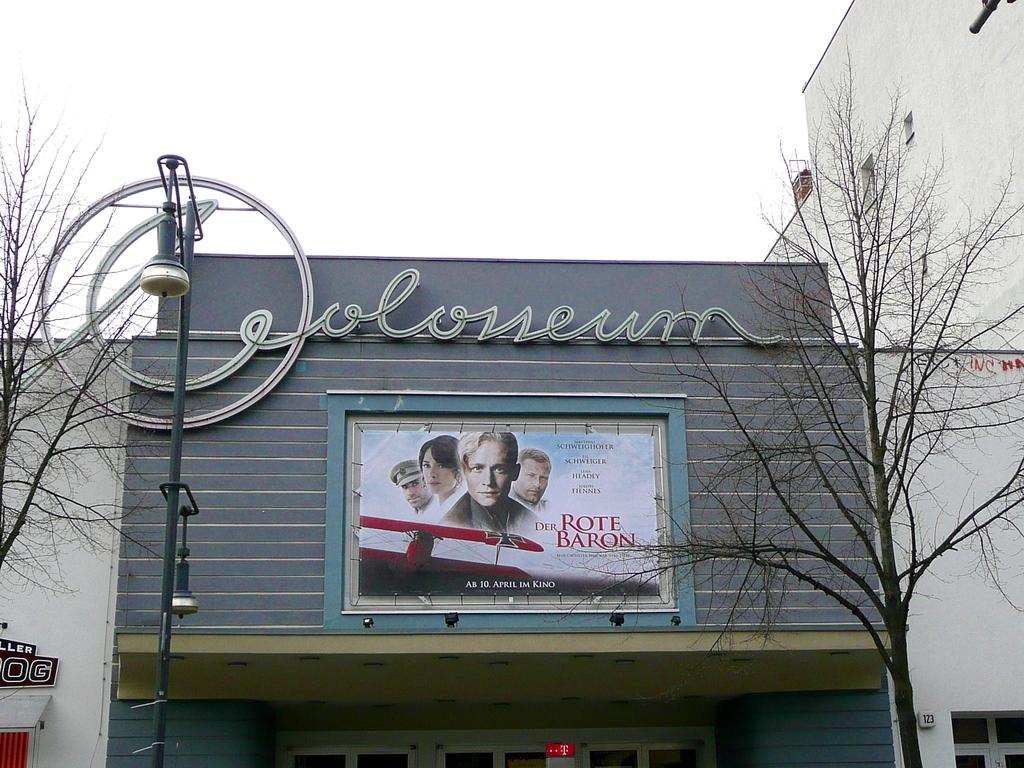Provide a one-sentence caption for the provided image. A picture of a theatre entrance with a poster advertising Der Rote Baron. 